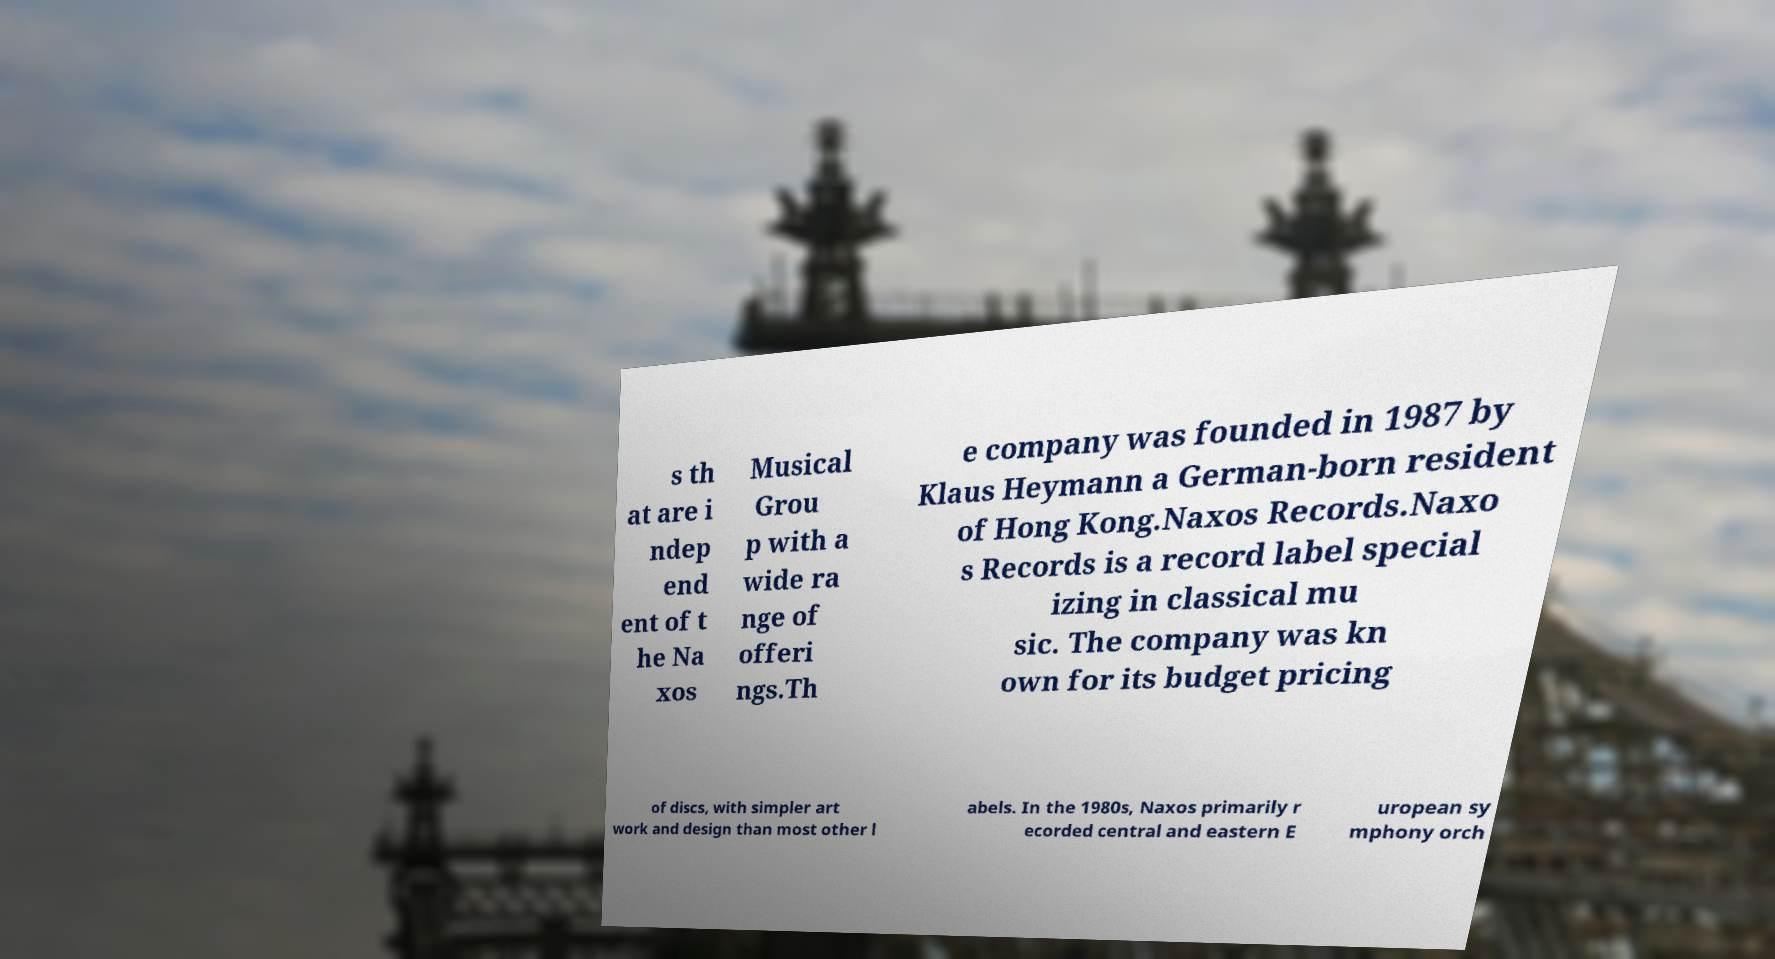Could you assist in decoding the text presented in this image and type it out clearly? s th at are i ndep end ent of t he Na xos Musical Grou p with a wide ra nge of offeri ngs.Th e company was founded in 1987 by Klaus Heymann a German-born resident of Hong Kong.Naxos Records.Naxo s Records is a record label special izing in classical mu sic. The company was kn own for its budget pricing of discs, with simpler art work and design than most other l abels. In the 1980s, Naxos primarily r ecorded central and eastern E uropean sy mphony orch 